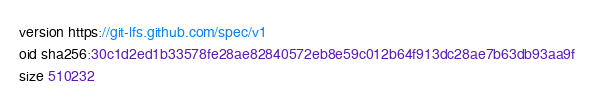Convert code to text. <code><loc_0><loc_0><loc_500><loc_500><_TypeScript_>version https://git-lfs.github.com/spec/v1
oid sha256:30c1d2ed1b33578fe28ae82840572eb8e59c012b64f913dc28ae7b63db93aa9f
size 510232
</code> 